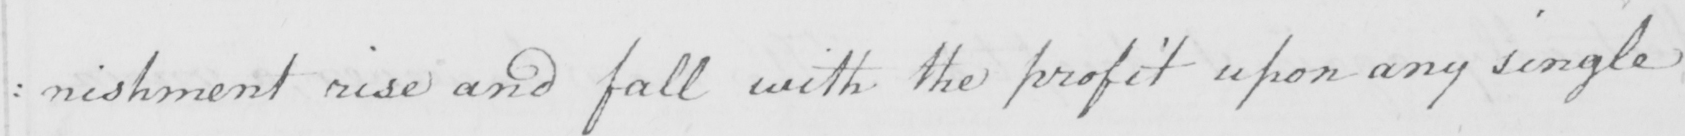Transcribe the text shown in this historical manuscript line. : nishment rise and fall with the profit upon any single 